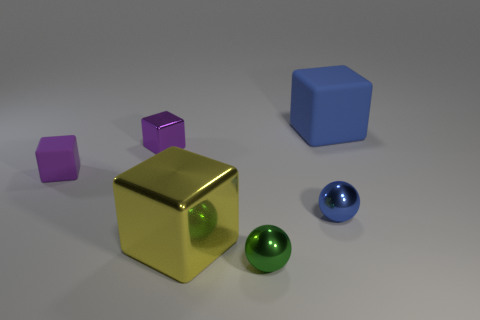There is another small block that is the same color as the small metal cube; what is it made of?
Offer a terse response. Rubber. What number of blocks have the same color as the tiny matte object?
Provide a short and direct response. 1. Is the size of the yellow block the same as the purple shiny cube?
Provide a succinct answer. No. Is the big blue thing on the right side of the purple matte object made of the same material as the large object on the left side of the big blue thing?
Make the answer very short. No. The metallic object that is on the left side of the large thing to the left of the rubber cube that is behind the tiny purple rubber thing is what shape?
Offer a very short reply. Cube. Are there more tiny purple objects than small green metallic balls?
Offer a very short reply. Yes. Are there any tiny yellow rubber cylinders?
Give a very brief answer. No. How many things are either small blue metallic objects behind the green sphere or cubes left of the big blue object?
Make the answer very short. 4. Does the tiny shiny block have the same color as the small rubber block?
Keep it short and to the point. Yes. Are there fewer small metal balls than big blue rubber things?
Ensure brevity in your answer.  No. 